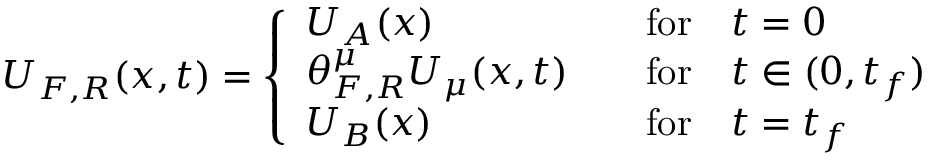Convert formula to latex. <formula><loc_0><loc_0><loc_500><loc_500>U _ { F , R } ( { x } , t ) = \left \{ \begin{array} { l l } { U _ { A } ( { x } ) } & { \quad f o r \quad t = 0 } \\ { \theta _ { F , R } ^ { \mu } U _ { \mu } ( { x } , t ) } & { \quad f o r \quad t \in ( 0 , t _ { f } ) } \\ { U _ { B } ( { x } ) } & { \quad f o r \quad t = t _ { f } } \end{array}</formula> 